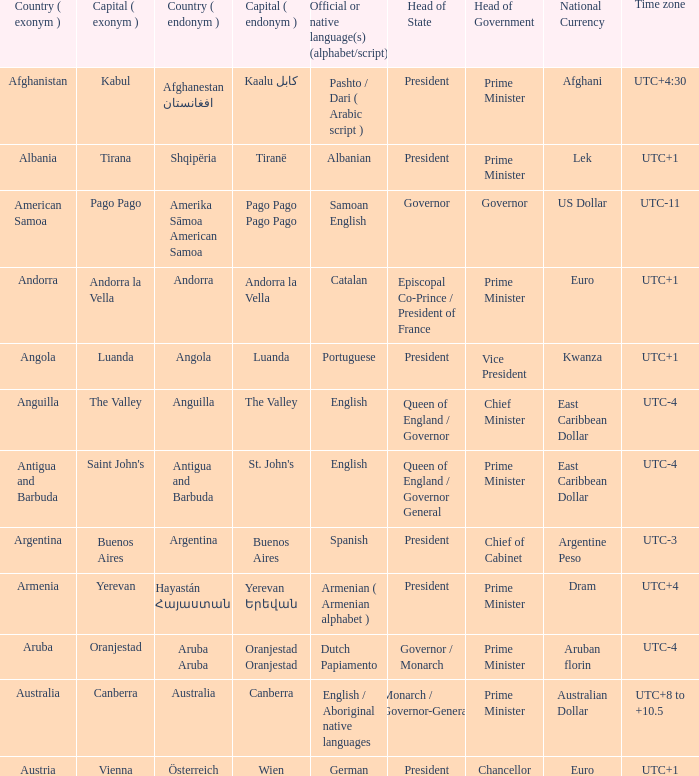Parse the table in full. {'header': ['Country ( exonym )', 'Capital ( exonym )', 'Country ( endonym )', 'Capital ( endonym )', 'Official or native language(s) (alphabet/script)', 'Head of State', 'Head of Government', 'National Currency', 'Time zone'], 'rows': [['Afghanistan', 'Kabul', 'Afghanestan افغانستان', 'Kaalu كابل', 'Pashto / Dari ( Arabic script )', 'President', 'Prime Minister', 'Afghani', 'UTC+4:30'], ['Albania', 'Tirana', 'Shqipëria', 'Tiranë', 'Albanian', 'President', 'Prime Minister', 'Lek', 'UTC+1'], ['American Samoa', 'Pago Pago', 'Amerika Sāmoa American Samoa', 'Pago Pago Pago Pago', 'Samoan English', 'Governor', 'Governor', 'US Dollar', 'UTC-11'], ['Andorra', 'Andorra la Vella', 'Andorra', 'Andorra la Vella', 'Catalan', 'Episcopal Co-Prince / President of France', 'Prime Minister', 'Euro', 'UTC+1'], ['Angola', 'Luanda', 'Angola', 'Luanda', 'Portuguese', 'President', 'Vice President', 'Kwanza', 'UTC+1'], ['Anguilla', 'The Valley', 'Anguilla', 'The Valley', 'English', 'Queen of England / Governor', 'Chief Minister', 'East Caribbean Dollar', 'UTC-4'], ['Antigua and Barbuda', "Saint John's", 'Antigua and Barbuda', "St. John's", 'English', 'Queen of England / Governor General', 'Prime Minister', 'East Caribbean Dollar', 'UTC-4'], ['Argentina', 'Buenos Aires', 'Argentina', 'Buenos Aires', 'Spanish', 'President', 'Chief of Cabinet', 'Argentine Peso', 'UTC-3'], ['Armenia', 'Yerevan', 'Hayastán Հայաստան', 'Yerevan Երեվան', 'Armenian ( Armenian alphabet )', 'President', 'Prime Minister', 'Dram', 'UTC+4'], ['Aruba', 'Oranjestad', 'Aruba Aruba', 'Oranjestad Oranjestad', 'Dutch Papiamento', 'Governor / Monarch', 'Prime Minister', 'Aruban florin', 'UTC-4'], ['Australia', 'Canberra', 'Australia', 'Canberra', 'English / Aboriginal native languages', 'Monarch / Governor-General', 'Prime Minister', 'Australian Dollar', 'UTC+8 to +10.5'], ['Austria', 'Vienna', 'Österreich', 'Wien', 'German', 'President', 'Chancellor', 'Euro', 'UTC+1']]} What is the English name of the country whose official native language is Dutch Papiamento? Aruba. 